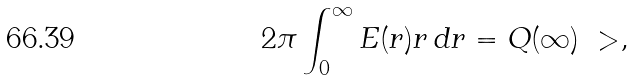Convert formula to latex. <formula><loc_0><loc_0><loc_500><loc_500>2 \pi \int _ { 0 } ^ { \infty } E ( r ) r \, d r = Q ( \infty ) \ > ,</formula> 